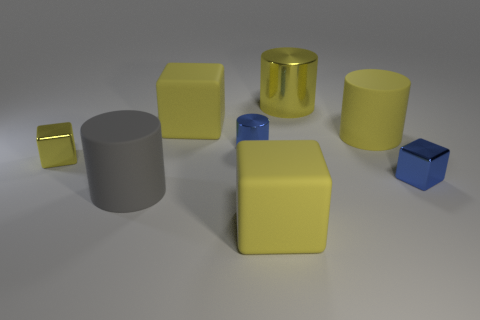Is the material of the big yellow cylinder behind the yellow matte cylinder the same as the gray object?
Keep it short and to the point. No. What is the shape of the big yellow thing that is in front of the large gray object that is in front of the big rubber cylinder to the right of the big metallic cylinder?
Your answer should be very brief. Cube. Are there an equal number of blue shiny blocks that are to the left of the tiny blue cube and blue metallic blocks that are on the left side of the yellow metallic cube?
Your answer should be very brief. Yes. What is the color of the other block that is the same size as the blue shiny cube?
Your answer should be very brief. Yellow. What number of large things are matte objects or gray things?
Offer a terse response. 4. What material is the big thing that is in front of the yellow matte cylinder and to the left of the tiny shiny cylinder?
Your answer should be compact. Rubber. There is a blue metallic thing on the right side of the small metallic cylinder; is it the same shape as the tiny thing on the left side of the small blue metallic cylinder?
Make the answer very short. Yes. What shape is the thing that is the same color as the tiny cylinder?
Give a very brief answer. Cube. What number of things are blocks behind the large gray cylinder or large matte things?
Your answer should be compact. 6. Is the yellow shiny cylinder the same size as the yellow rubber cylinder?
Provide a short and direct response. Yes. 